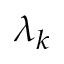Convert formula to latex. <formula><loc_0><loc_0><loc_500><loc_500>\lambda _ { k }</formula> 